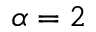Convert formula to latex. <formula><loc_0><loc_0><loc_500><loc_500>\alpha = 2</formula> 